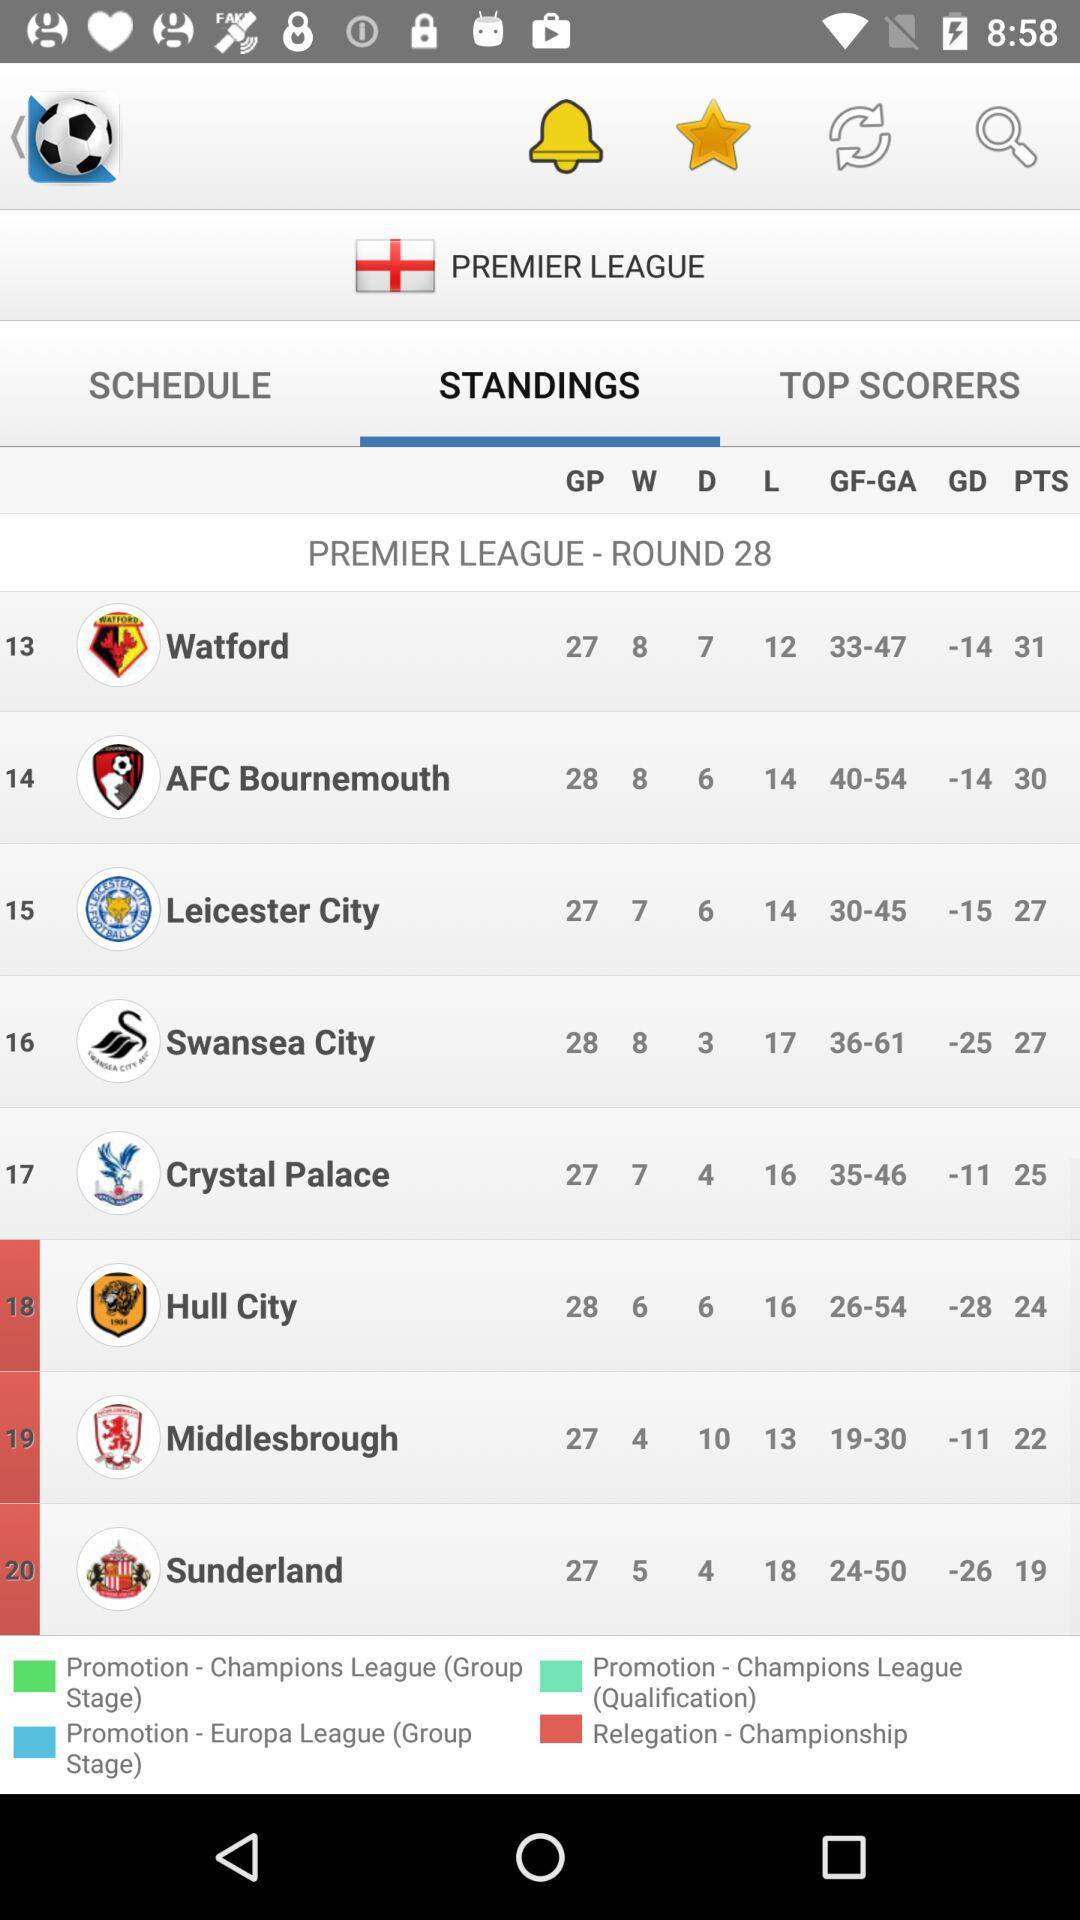What is the selected tab? The selected tab is "STANDINGS". 